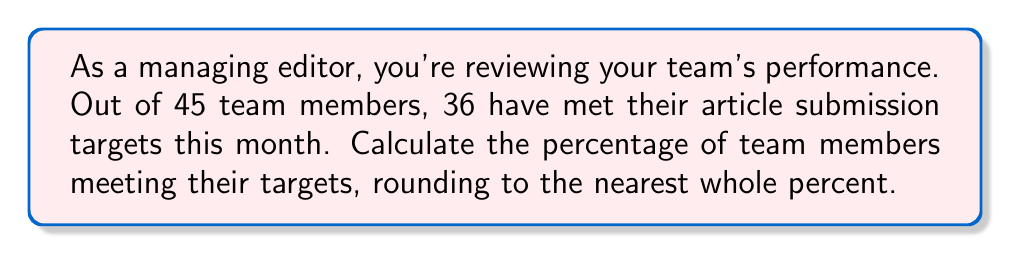Give your solution to this math problem. Let's approach this step-by-step:

1) First, we need to set up the ratio of team members meeting targets to total team members:
   
   $\frac{\text{Members meeting targets}}{\text{Total members}} = \frac{36}{45}$

2) To convert this to a percentage, we multiply by 100:

   $\frac{36}{45} \times 100 = \text{Percentage}$

3) Let's perform the division:

   $\frac{36}{45} = 0.8$

4) Now multiply by 100:

   $0.8 \times 100 = 80$

5) The question asks to round to the nearest whole percent, but 80 is already a whole number, so no rounding is necessary.

Therefore, 80% of team members are meeting their targets.
Answer: 80% 